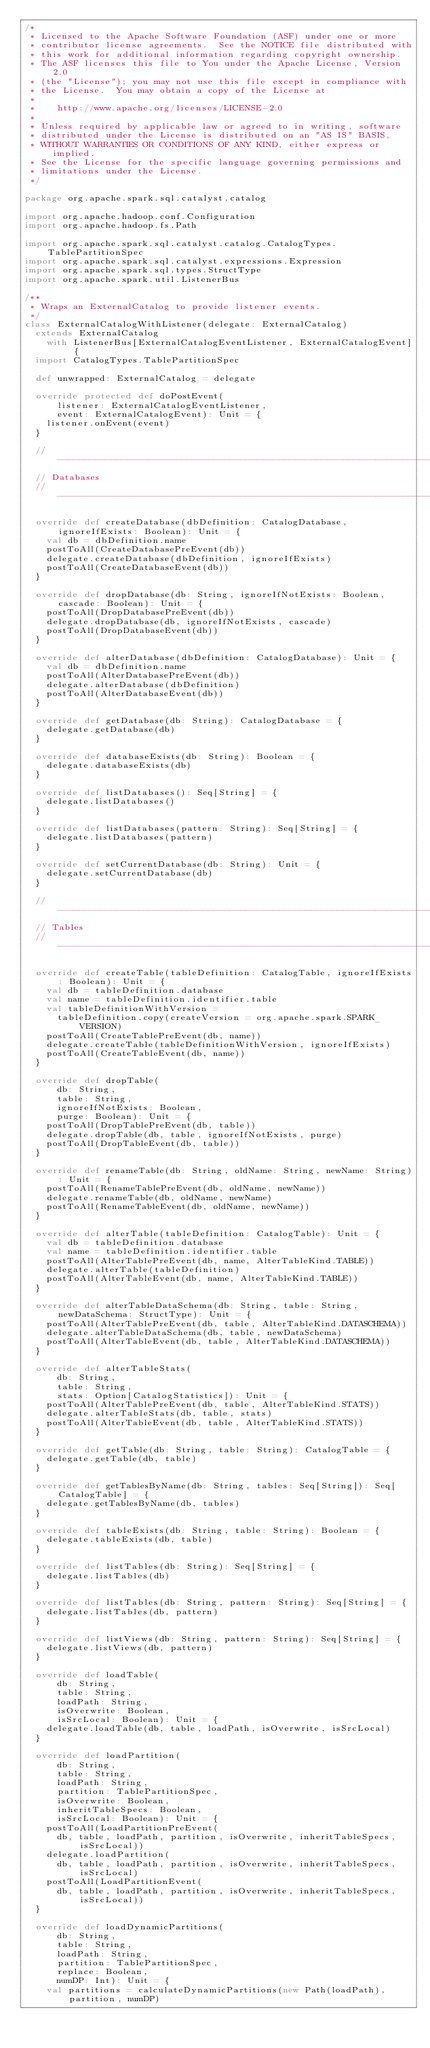<code> <loc_0><loc_0><loc_500><loc_500><_Scala_>/*
 * Licensed to the Apache Software Foundation (ASF) under one or more
 * contributor license agreements.  See the NOTICE file distributed with
 * this work for additional information regarding copyright ownership.
 * The ASF licenses this file to You under the Apache License, Version 2.0
 * (the "License"); you may not use this file except in compliance with
 * the License.  You may obtain a copy of the License at
 *
 *    http://www.apache.org/licenses/LICENSE-2.0
 *
 * Unless required by applicable law or agreed to in writing, software
 * distributed under the License is distributed on an "AS IS" BASIS,
 * WITHOUT WARRANTIES OR CONDITIONS OF ANY KIND, either express or implied.
 * See the License for the specific language governing permissions and
 * limitations under the License.
 */

package org.apache.spark.sql.catalyst.catalog

import org.apache.hadoop.conf.Configuration
import org.apache.hadoop.fs.Path

import org.apache.spark.sql.catalyst.catalog.CatalogTypes.TablePartitionSpec
import org.apache.spark.sql.catalyst.expressions.Expression
import org.apache.spark.sql.types.StructType
import org.apache.spark.util.ListenerBus

/**
 * Wraps an ExternalCatalog to provide listener events.
 */
class ExternalCatalogWithListener(delegate: ExternalCatalog)
  extends ExternalCatalog
    with ListenerBus[ExternalCatalogEventListener, ExternalCatalogEvent] {
  import CatalogTypes.TablePartitionSpec

  def unwrapped: ExternalCatalog = delegate

  override protected def doPostEvent(
      listener: ExternalCatalogEventListener,
      event: ExternalCatalogEvent): Unit = {
    listener.onEvent(event)
  }

  // --------------------------------------------------------------------------
  // Databases
  // --------------------------------------------------------------------------

  override def createDatabase(dbDefinition: CatalogDatabase, ignoreIfExists: Boolean): Unit = {
    val db = dbDefinition.name
    postToAll(CreateDatabasePreEvent(db))
    delegate.createDatabase(dbDefinition, ignoreIfExists)
    postToAll(CreateDatabaseEvent(db))
  }

  override def dropDatabase(db: String, ignoreIfNotExists: Boolean, cascade: Boolean): Unit = {
    postToAll(DropDatabasePreEvent(db))
    delegate.dropDatabase(db, ignoreIfNotExists, cascade)
    postToAll(DropDatabaseEvent(db))
  }

  override def alterDatabase(dbDefinition: CatalogDatabase): Unit = {
    val db = dbDefinition.name
    postToAll(AlterDatabasePreEvent(db))
    delegate.alterDatabase(dbDefinition)
    postToAll(AlterDatabaseEvent(db))
  }

  override def getDatabase(db: String): CatalogDatabase = {
    delegate.getDatabase(db)
  }

  override def databaseExists(db: String): Boolean = {
    delegate.databaseExists(db)
  }

  override def listDatabases(): Seq[String] = {
    delegate.listDatabases()
  }

  override def listDatabases(pattern: String): Seq[String] = {
    delegate.listDatabases(pattern)
  }

  override def setCurrentDatabase(db: String): Unit = {
    delegate.setCurrentDatabase(db)
  }

  // --------------------------------------------------------------------------
  // Tables
  // --------------------------------------------------------------------------

  override def createTable(tableDefinition: CatalogTable, ignoreIfExists: Boolean): Unit = {
    val db = tableDefinition.database
    val name = tableDefinition.identifier.table
    val tableDefinitionWithVersion =
      tableDefinition.copy(createVersion = org.apache.spark.SPARK_VERSION)
    postToAll(CreateTablePreEvent(db, name))
    delegate.createTable(tableDefinitionWithVersion, ignoreIfExists)
    postToAll(CreateTableEvent(db, name))
  }

  override def dropTable(
      db: String,
      table: String,
      ignoreIfNotExists: Boolean,
      purge: Boolean): Unit = {
    postToAll(DropTablePreEvent(db, table))
    delegate.dropTable(db, table, ignoreIfNotExists, purge)
    postToAll(DropTableEvent(db, table))
  }

  override def renameTable(db: String, oldName: String, newName: String): Unit = {
    postToAll(RenameTablePreEvent(db, oldName, newName))
    delegate.renameTable(db, oldName, newName)
    postToAll(RenameTableEvent(db, oldName, newName))
  }

  override def alterTable(tableDefinition: CatalogTable): Unit = {
    val db = tableDefinition.database
    val name = tableDefinition.identifier.table
    postToAll(AlterTablePreEvent(db, name, AlterTableKind.TABLE))
    delegate.alterTable(tableDefinition)
    postToAll(AlterTableEvent(db, name, AlterTableKind.TABLE))
  }

  override def alterTableDataSchema(db: String, table: String, newDataSchema: StructType): Unit = {
    postToAll(AlterTablePreEvent(db, table, AlterTableKind.DATASCHEMA))
    delegate.alterTableDataSchema(db, table, newDataSchema)
    postToAll(AlterTableEvent(db, table, AlterTableKind.DATASCHEMA))
  }

  override def alterTableStats(
      db: String,
      table: String,
      stats: Option[CatalogStatistics]): Unit = {
    postToAll(AlterTablePreEvent(db, table, AlterTableKind.STATS))
    delegate.alterTableStats(db, table, stats)
    postToAll(AlterTableEvent(db, table, AlterTableKind.STATS))
  }

  override def getTable(db: String, table: String): CatalogTable = {
    delegate.getTable(db, table)
  }

  override def getTablesByName(db: String, tables: Seq[String]): Seq[CatalogTable] = {
    delegate.getTablesByName(db, tables)
  }

  override def tableExists(db: String, table: String): Boolean = {
    delegate.tableExists(db, table)
  }

  override def listTables(db: String): Seq[String] = {
    delegate.listTables(db)
  }

  override def listTables(db: String, pattern: String): Seq[String] = {
    delegate.listTables(db, pattern)
  }

  override def listViews(db: String, pattern: String): Seq[String] = {
    delegate.listViews(db, pattern)
  }

  override def loadTable(
      db: String,
      table: String,
      loadPath: String,
      isOverwrite: Boolean,
      isSrcLocal: Boolean): Unit = {
    delegate.loadTable(db, table, loadPath, isOverwrite, isSrcLocal)
  }

  override def loadPartition(
      db: String,
      table: String,
      loadPath: String,
      partition: TablePartitionSpec,
      isOverwrite: Boolean,
      inheritTableSpecs: Boolean,
      isSrcLocal: Boolean): Unit = {
    postToAll(LoadPartitionPreEvent(
      db, table, loadPath, partition, isOverwrite, inheritTableSpecs, isSrcLocal))
    delegate.loadPartition(
      db, table, loadPath, partition, isOverwrite, inheritTableSpecs, isSrcLocal)
    postToAll(LoadPartitionEvent(
      db, table, loadPath, partition, isOverwrite, inheritTableSpecs, isSrcLocal))
  }

  override def loadDynamicPartitions(
      db: String,
      table: String,
      loadPath: String,
      partition: TablePartitionSpec,
      replace: Boolean,
      numDP: Int): Unit = {
    val partitions = calculateDynamicPartitions(new Path(loadPath), partition, numDP)</code> 